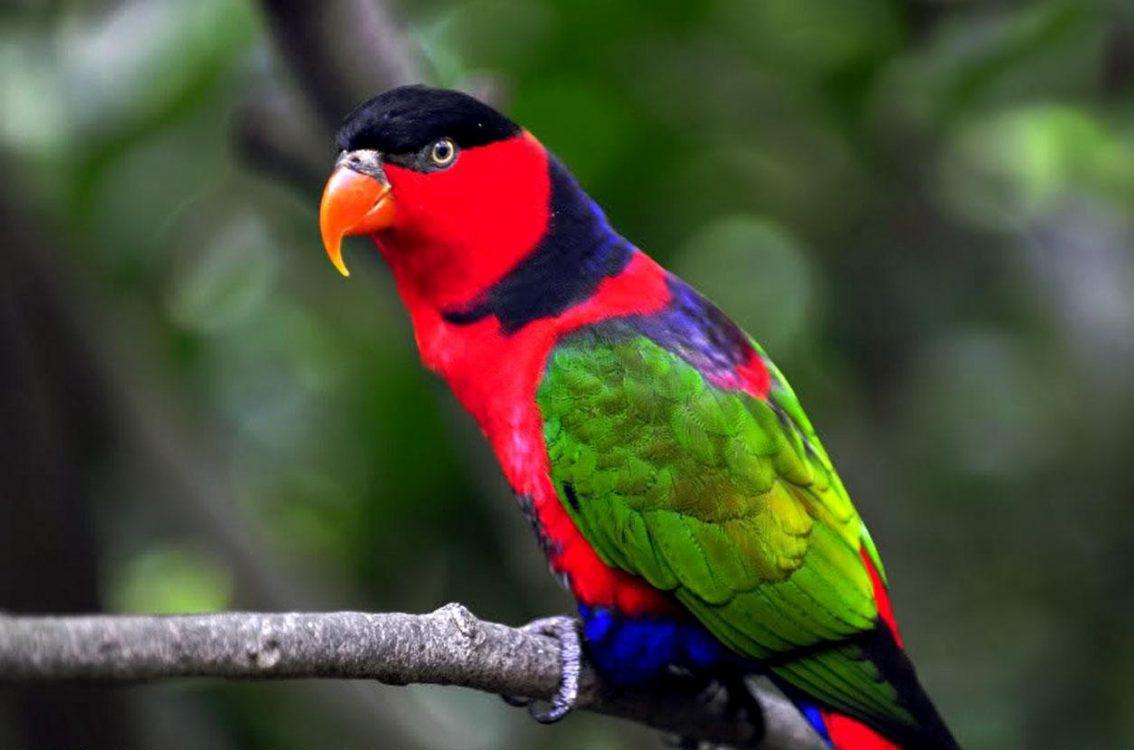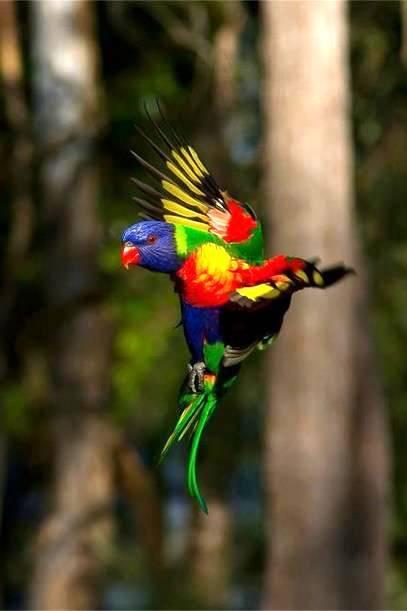The first image is the image on the left, the second image is the image on the right. Assess this claim about the two images: "An image shows a single parrot which is not in flight.". Correct or not? Answer yes or no. Yes. 